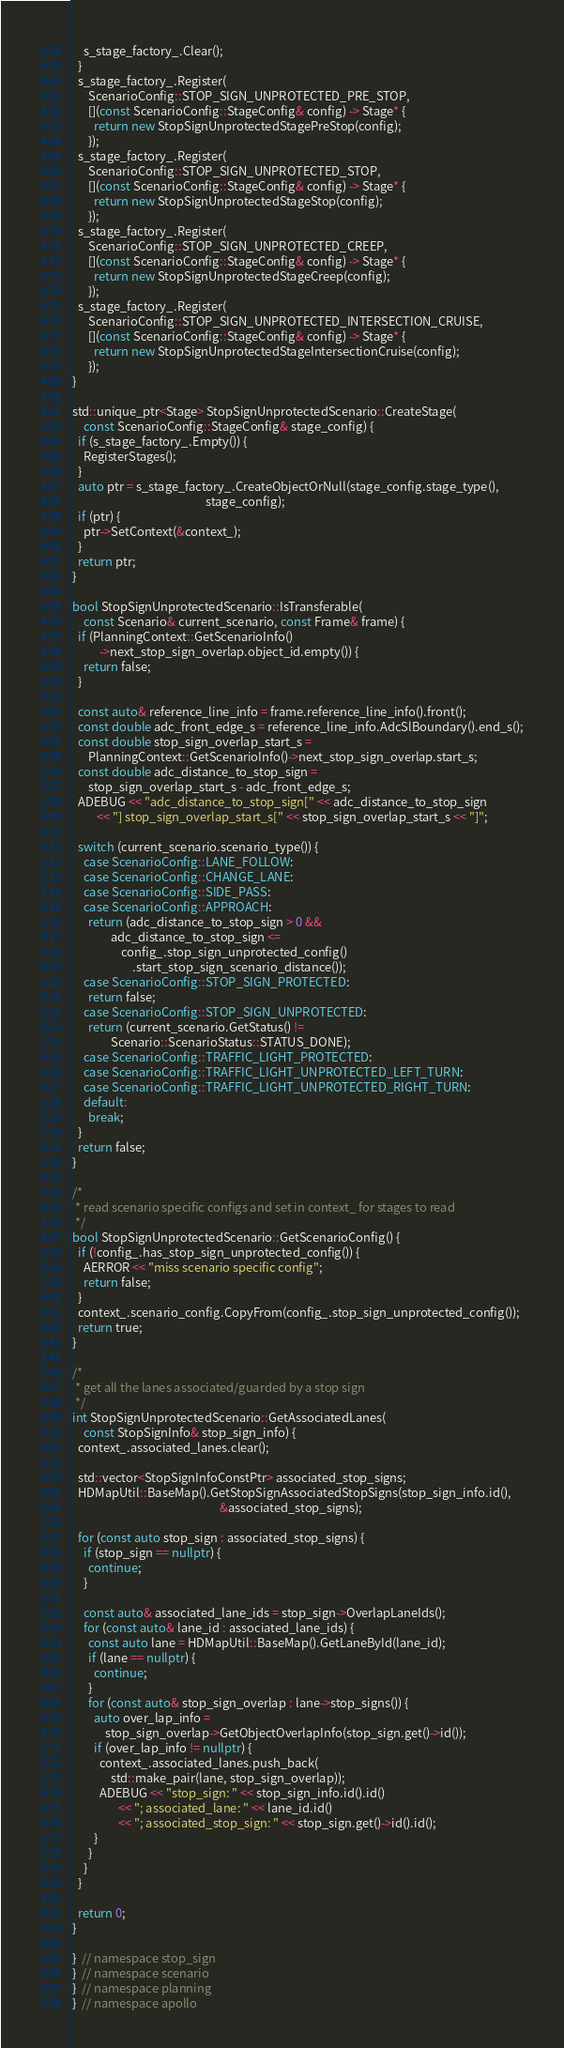<code> <loc_0><loc_0><loc_500><loc_500><_C++_>    s_stage_factory_.Clear();
  }
  s_stage_factory_.Register(
      ScenarioConfig::STOP_SIGN_UNPROTECTED_PRE_STOP,
      [](const ScenarioConfig::StageConfig& config) -> Stage* {
        return new StopSignUnprotectedStagePreStop(config);
      });
  s_stage_factory_.Register(
      ScenarioConfig::STOP_SIGN_UNPROTECTED_STOP,
      [](const ScenarioConfig::StageConfig& config) -> Stage* {
        return new StopSignUnprotectedStageStop(config);
      });
  s_stage_factory_.Register(
      ScenarioConfig::STOP_SIGN_UNPROTECTED_CREEP,
      [](const ScenarioConfig::StageConfig& config) -> Stage* {
        return new StopSignUnprotectedStageCreep(config);
      });
  s_stage_factory_.Register(
      ScenarioConfig::STOP_SIGN_UNPROTECTED_INTERSECTION_CRUISE,
      [](const ScenarioConfig::StageConfig& config) -> Stage* {
        return new StopSignUnprotectedStageIntersectionCruise(config);
      });
}

std::unique_ptr<Stage> StopSignUnprotectedScenario::CreateStage(
    const ScenarioConfig::StageConfig& stage_config) {
  if (s_stage_factory_.Empty()) {
    RegisterStages();
  }
  auto ptr = s_stage_factory_.CreateObjectOrNull(stage_config.stage_type(),
                                                 stage_config);
  if (ptr) {
    ptr->SetContext(&context_);
  }
  return ptr;
}

bool StopSignUnprotectedScenario::IsTransferable(
    const Scenario& current_scenario, const Frame& frame) {
  if (PlanningContext::GetScenarioInfo()
          ->next_stop_sign_overlap.object_id.empty()) {
    return false;
  }

  const auto& reference_line_info = frame.reference_line_info().front();
  const double adc_front_edge_s = reference_line_info.AdcSlBoundary().end_s();
  const double stop_sign_overlap_start_s =
      PlanningContext::GetScenarioInfo()->next_stop_sign_overlap.start_s;
  const double adc_distance_to_stop_sign =
      stop_sign_overlap_start_s - adc_front_edge_s;
  ADEBUG << "adc_distance_to_stop_sign[" << adc_distance_to_stop_sign
         << "] stop_sign_overlap_start_s[" << stop_sign_overlap_start_s << "]";

  switch (current_scenario.scenario_type()) {
    case ScenarioConfig::LANE_FOLLOW:
    case ScenarioConfig::CHANGE_LANE:
    case ScenarioConfig::SIDE_PASS:
    case ScenarioConfig::APPROACH:
      return (adc_distance_to_stop_sign > 0 &&
              adc_distance_to_stop_sign <=
                  config_.stop_sign_unprotected_config()
                      .start_stop_sign_scenario_distance());
    case ScenarioConfig::STOP_SIGN_PROTECTED:
      return false;
    case ScenarioConfig::STOP_SIGN_UNPROTECTED:
      return (current_scenario.GetStatus() !=
              Scenario::ScenarioStatus::STATUS_DONE);
    case ScenarioConfig::TRAFFIC_LIGHT_PROTECTED:
    case ScenarioConfig::TRAFFIC_LIGHT_UNPROTECTED_LEFT_TURN:
    case ScenarioConfig::TRAFFIC_LIGHT_UNPROTECTED_RIGHT_TURN:
    default:
      break;
  }
  return false;
}

/*
 * read scenario specific configs and set in context_ for stages to read
 */
bool StopSignUnprotectedScenario::GetScenarioConfig() {
  if (!config_.has_stop_sign_unprotected_config()) {
    AERROR << "miss scenario specific config";
    return false;
  }
  context_.scenario_config.CopyFrom(config_.stop_sign_unprotected_config());
  return true;
}

/*
 * get all the lanes associated/guarded by a stop sign
 */
int StopSignUnprotectedScenario::GetAssociatedLanes(
    const StopSignInfo& stop_sign_info) {
  context_.associated_lanes.clear();

  std::vector<StopSignInfoConstPtr> associated_stop_signs;
  HDMapUtil::BaseMap().GetStopSignAssociatedStopSigns(stop_sign_info.id(),
                                                      &associated_stop_signs);

  for (const auto stop_sign : associated_stop_signs) {
    if (stop_sign == nullptr) {
      continue;
    }

    const auto& associated_lane_ids = stop_sign->OverlapLaneIds();
    for (const auto& lane_id : associated_lane_ids) {
      const auto lane = HDMapUtil::BaseMap().GetLaneById(lane_id);
      if (lane == nullptr) {
        continue;
      }
      for (const auto& stop_sign_overlap : lane->stop_signs()) {
        auto over_lap_info =
            stop_sign_overlap->GetObjectOverlapInfo(stop_sign.get()->id());
        if (over_lap_info != nullptr) {
          context_.associated_lanes.push_back(
              std::make_pair(lane, stop_sign_overlap));
          ADEBUG << "stop_sign: " << stop_sign_info.id().id()
                 << "; associated_lane: " << lane_id.id()
                 << "; associated_stop_sign: " << stop_sign.get()->id().id();
        }
      }
    }
  }

  return 0;
}

}  // namespace stop_sign
}  // namespace scenario
}  // namespace planning
}  // namespace apollo
</code> 